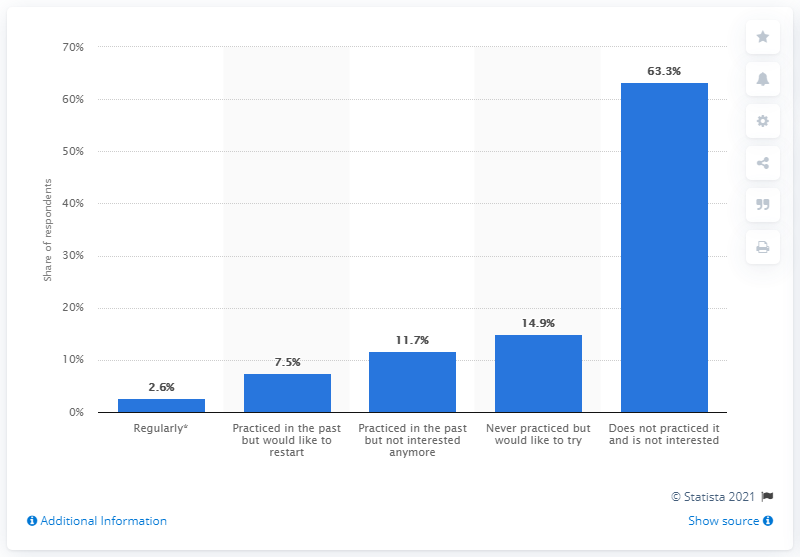Give some essential details in this illustration. Sixthirtythree percent of Italian women did not participate in athletics. 